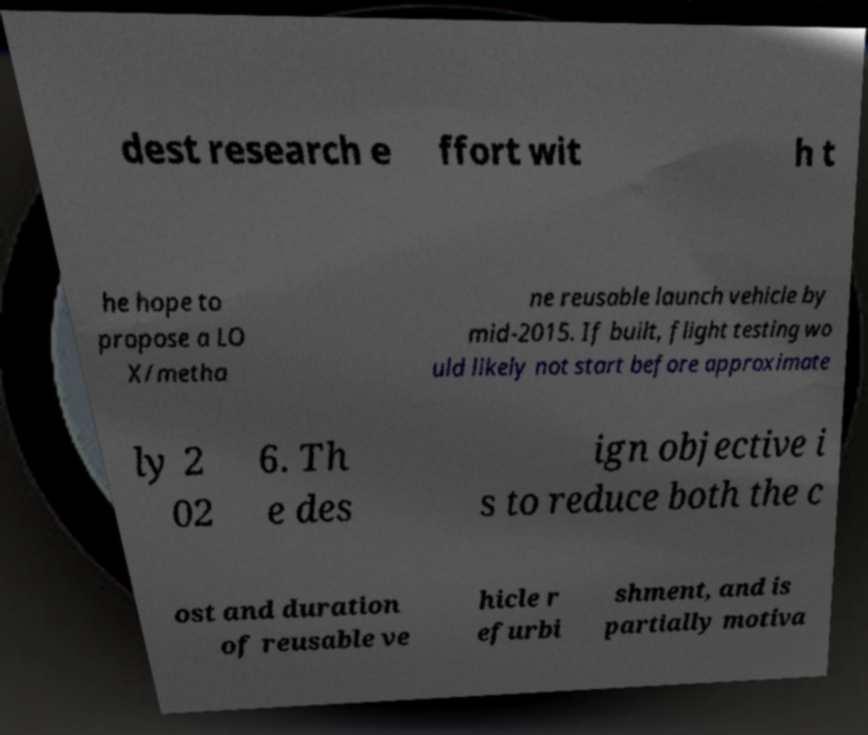Please read and relay the text visible in this image. What does it say? dest research e ffort wit h t he hope to propose a LO X/metha ne reusable launch vehicle by mid-2015. If built, flight testing wo uld likely not start before approximate ly 2 02 6. Th e des ign objective i s to reduce both the c ost and duration of reusable ve hicle r efurbi shment, and is partially motiva 